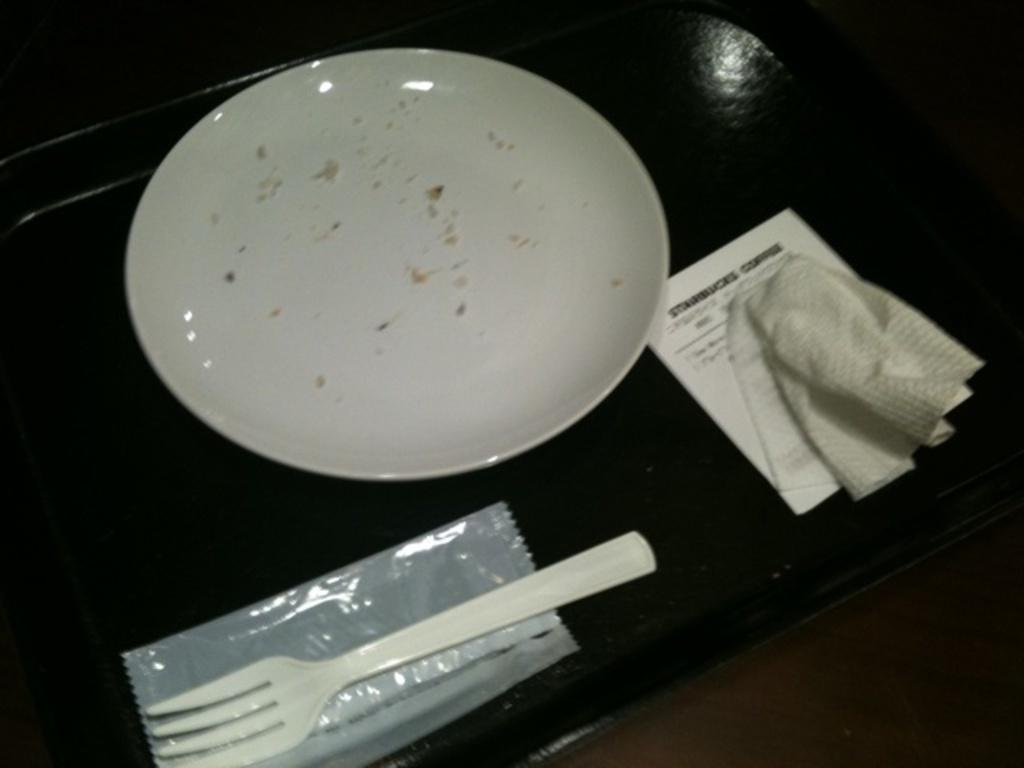What is one of the items placed on the table in the image? There is a plate in the image. What utensil is visible in the image? There is a fork in the image. What might be used for wiping or drying in the image? There is a napkin in the image. What type of material is present in the image? There is paper in the image. What surface is holding all of these items in the image? All of these items are placed on a table in the image. What type of metal is used to make the haircut visible in the image? There is no haircut present in the image, and therefore no metal can be associated with it. 